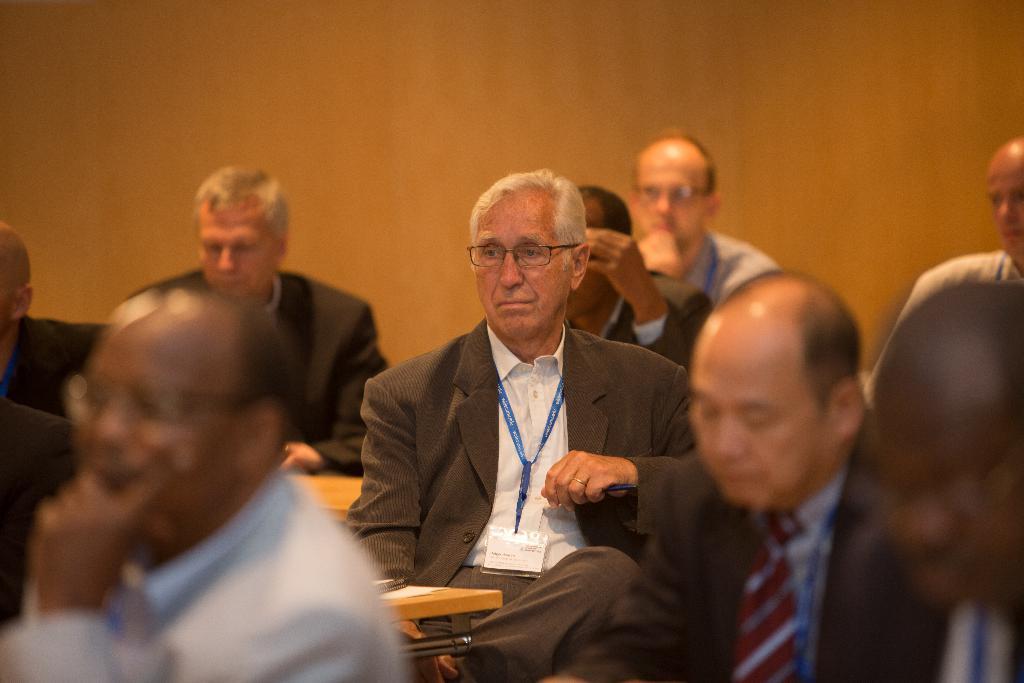In one or two sentences, can you explain what this image depicts? In this image I can see a person wearing white shirt, brown blazer and brown pant is sitting on a bench in front of a table and on the table I can see a paper. I can see few other persons sitting and in the background I can see the orange colored surface. 